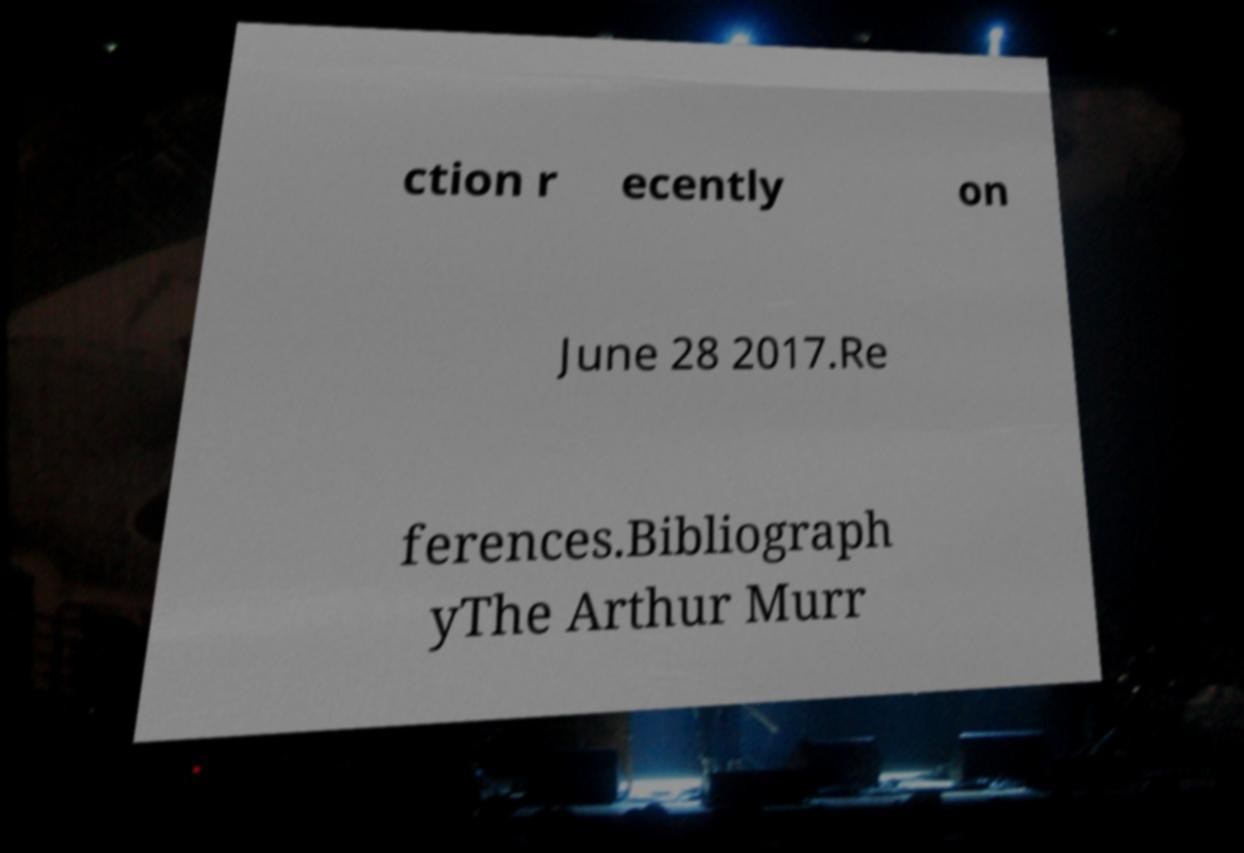Can you accurately transcribe the text from the provided image for me? ction r ecently on June 28 2017.Re ferences.Bibliograph yThe Arthur Murr 